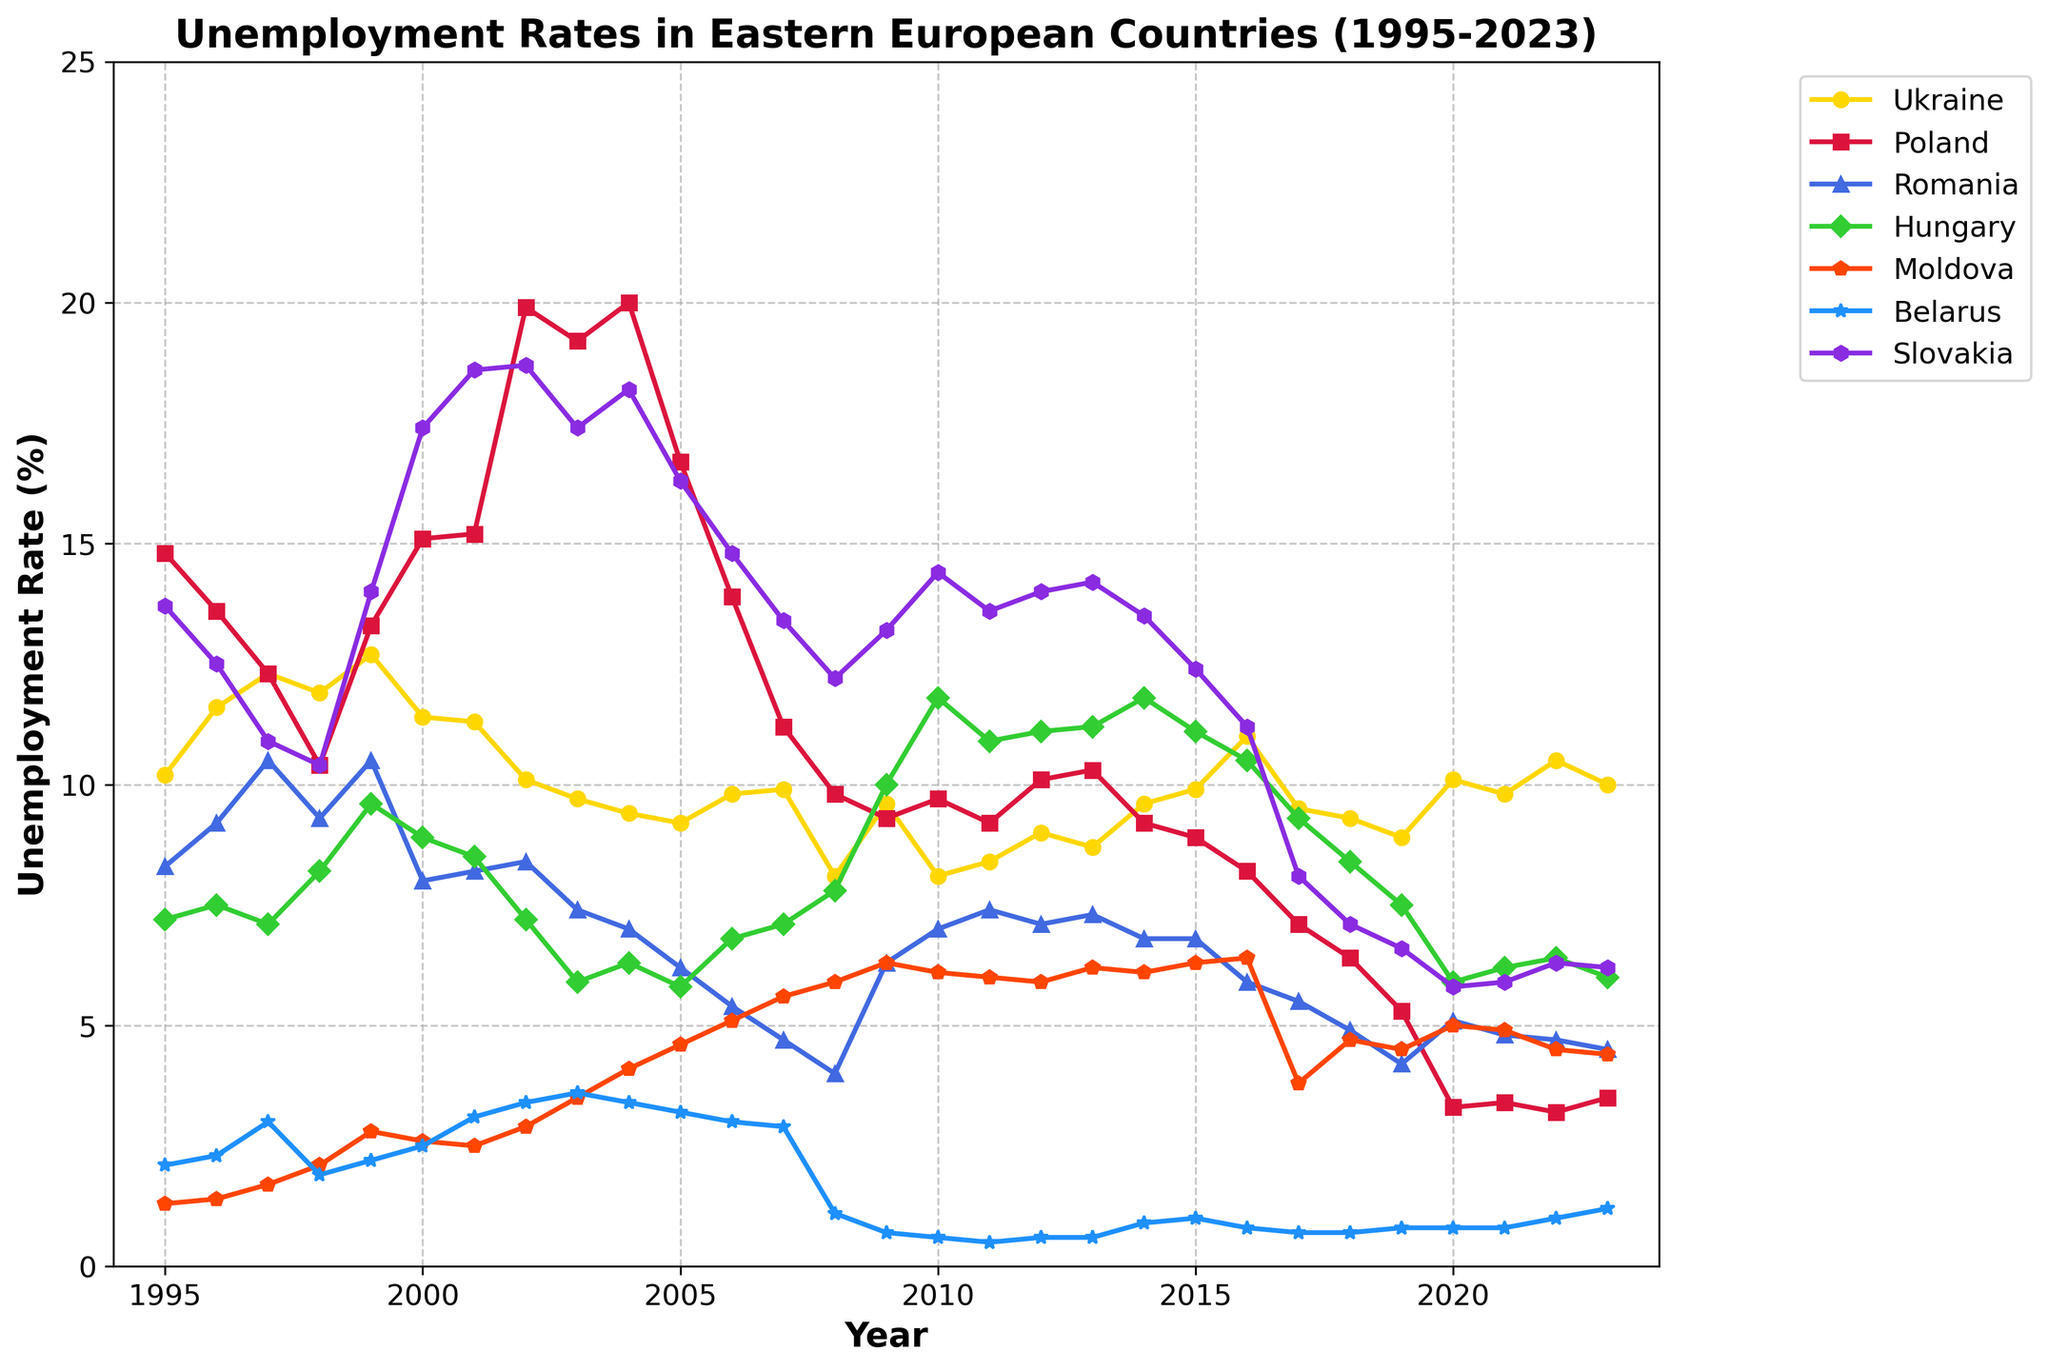What is the title of the figure? The title of the figure is usually displayed at the top of the plot. In this case, the title is clearly stated in bold.
Answer: Unemployment Rates in Eastern European Countries (1995-2023) Which country had the highest unemployment rate in 2023? To find the country with the highest unemployment rate in 2023, look at the values for each country in 2023. Compare all the values to identify the highest one.
Answer: Ukraine What was the lowest recorded unemployment rate for Poland? Scan through the values for Poland across all years and identify the lowest number.
Answer: 3.2% In which year did Slovakia experience its highest unemployment rate? Identify the peak value in the unemployment rate for Slovakia and refer to the corresponding year on the x-axis.
Answer: 2002 How did the unemployment rate in Ukraine change from 1999 to 2005? Observe the unemployment rate of Ukraine in 1999 and compare it to the rate in 2005. Track how the line representing Ukraine changes between these years.
Answer: It decreased from 12.7% to 9.2% Which two countries had almost identical unemployment rates in 2013 and what were those rates? Compare the unemployment rates of all countries in 2013 to find any that are very close to each other.
Answer: Hungary and Romania, both around 11.2% What is the general trend in the unemployment rate for Moldova from 1995 to 2023? Look at the line representing Moldova from the start year to the end year and assess whether it increases, decreases, or fluctuates.
Answer: Generally increasing Comparing 2002 and 2020, how did the unemployment rate change for Belarus? Identify the unemployment rate for Belarus in 2002 and compare it to the rate in 2020 to see how it changed.
Answer: It decreased from 3.4% to 0.8% Which country showed the most significant fluctuation in unemployment rates between 1995 and 2023? Analyze the lines representing each country and determine which one has the largest variability (peaks and troughs) over the years.
Answer: Poland What are the average unemployment rates for Ukraine and Slovakia over the given period? Calculate the mean of the unemployment rates for Ukraine and Slovakia from 1995 to 2023 by summing up all their yearly rates then dividing by the number of years.
Answer: Ukraine: 9.9%, Slovakia: 12.9% 